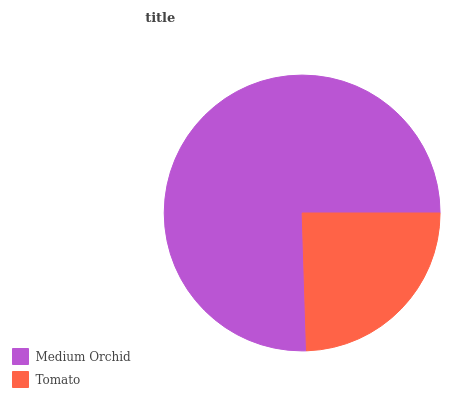Is Tomato the minimum?
Answer yes or no. Yes. Is Medium Orchid the maximum?
Answer yes or no. Yes. Is Tomato the maximum?
Answer yes or no. No. Is Medium Orchid greater than Tomato?
Answer yes or no. Yes. Is Tomato less than Medium Orchid?
Answer yes or no. Yes. Is Tomato greater than Medium Orchid?
Answer yes or no. No. Is Medium Orchid less than Tomato?
Answer yes or no. No. Is Medium Orchid the high median?
Answer yes or no. Yes. Is Tomato the low median?
Answer yes or no. Yes. Is Tomato the high median?
Answer yes or no. No. Is Medium Orchid the low median?
Answer yes or no. No. 